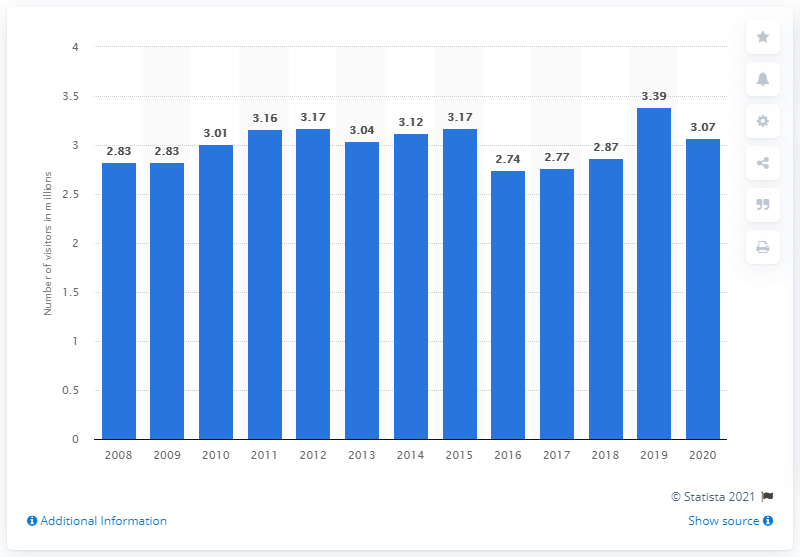It seems like there was a drop in visitors in 2020. Can you hypothesize reasons for this pattern? The observed drop in visitation numbers for the year 2020, as shown in the chart, could likely be attributed to the impact of the COVID-19 pandemic. Travel restrictions, lockdowns, and the public's concern for health and safety would have contributed to fewer people choosing or being able to visit recreational areas such as this one. 